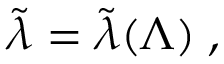Convert formula to latex. <formula><loc_0><loc_0><loc_500><loc_500>\tilde { \lambda } = \tilde { \lambda } ( \Lambda ) \, ,</formula> 